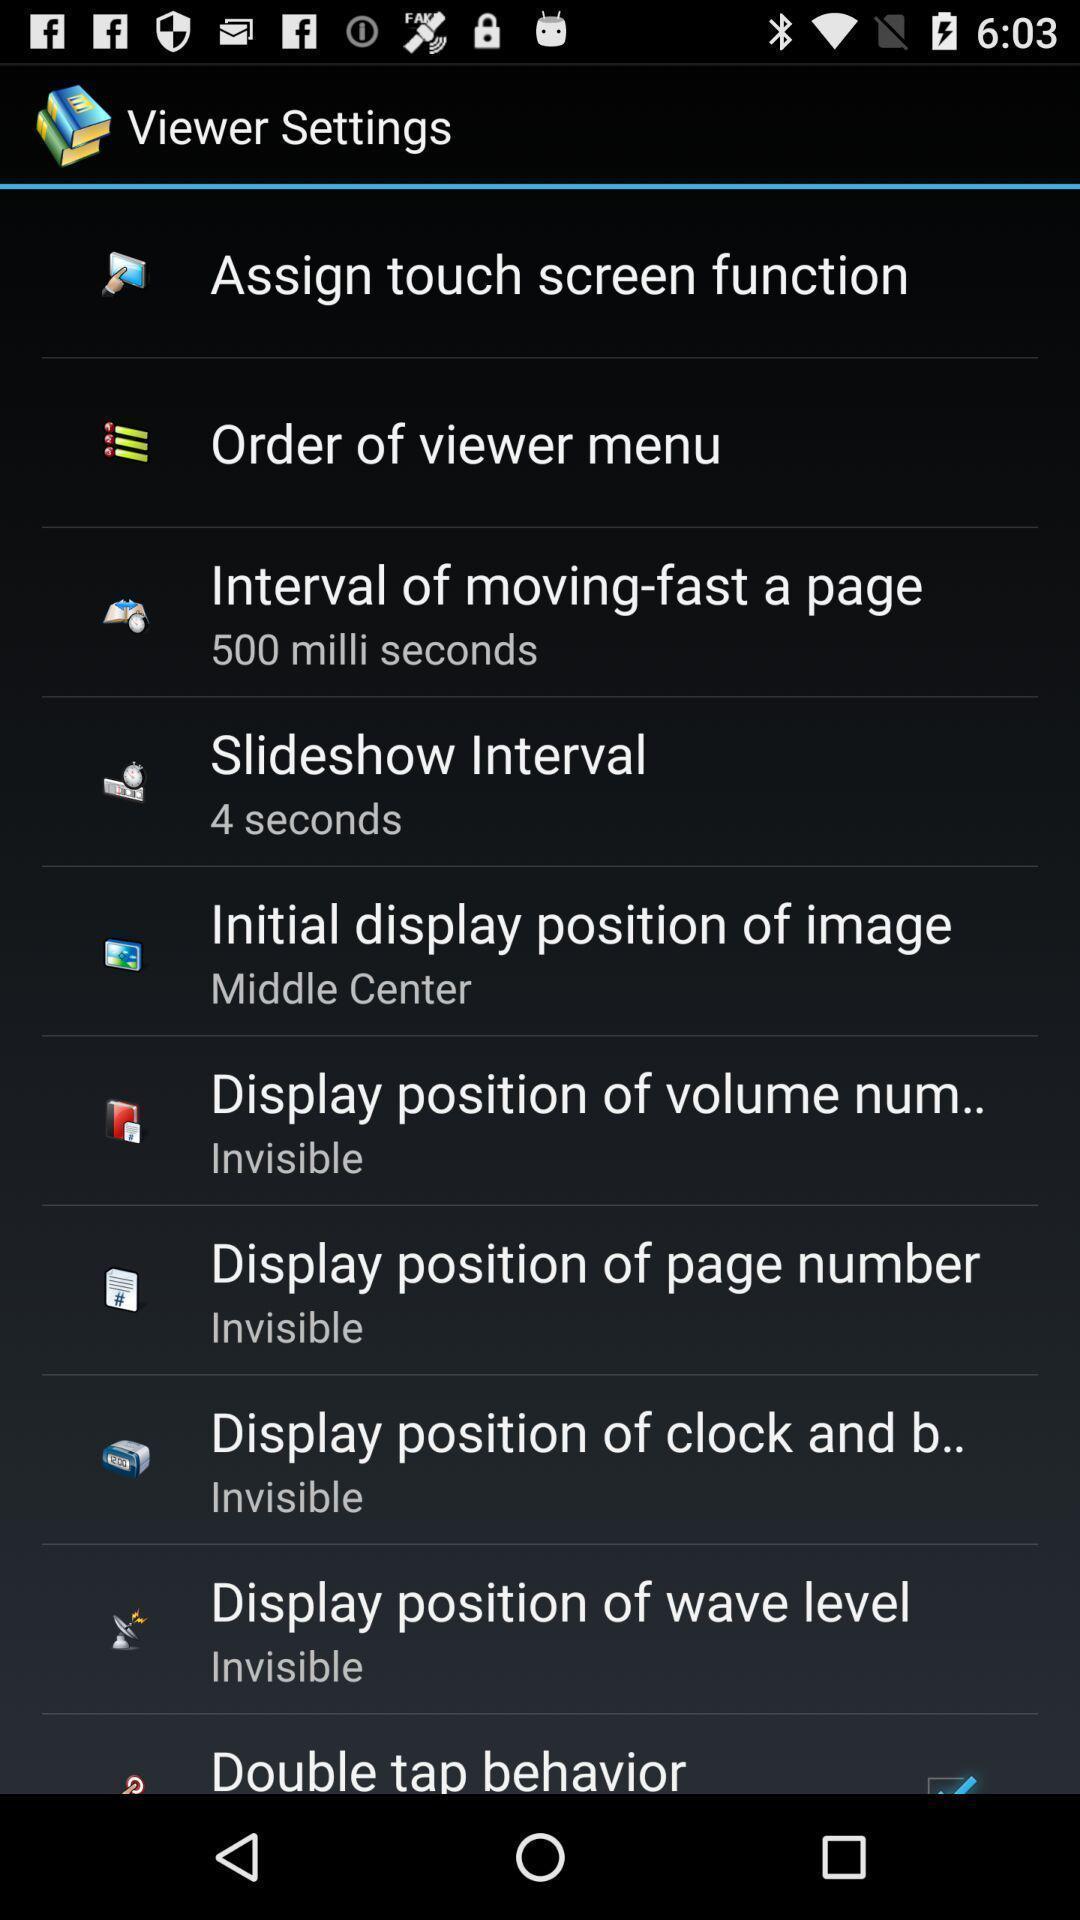What details can you identify in this image? Viewer settings page in a comic app. 